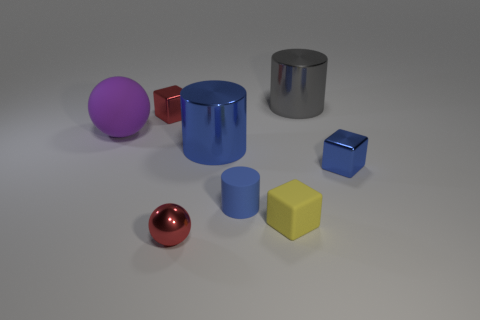Add 1 metallic things. How many objects exist? 9 Subtract all cylinders. How many objects are left? 5 Subtract all small blue things. Subtract all large purple things. How many objects are left? 5 Add 2 tiny cylinders. How many tiny cylinders are left? 3 Add 6 green balls. How many green balls exist? 6 Subtract 1 red cubes. How many objects are left? 7 